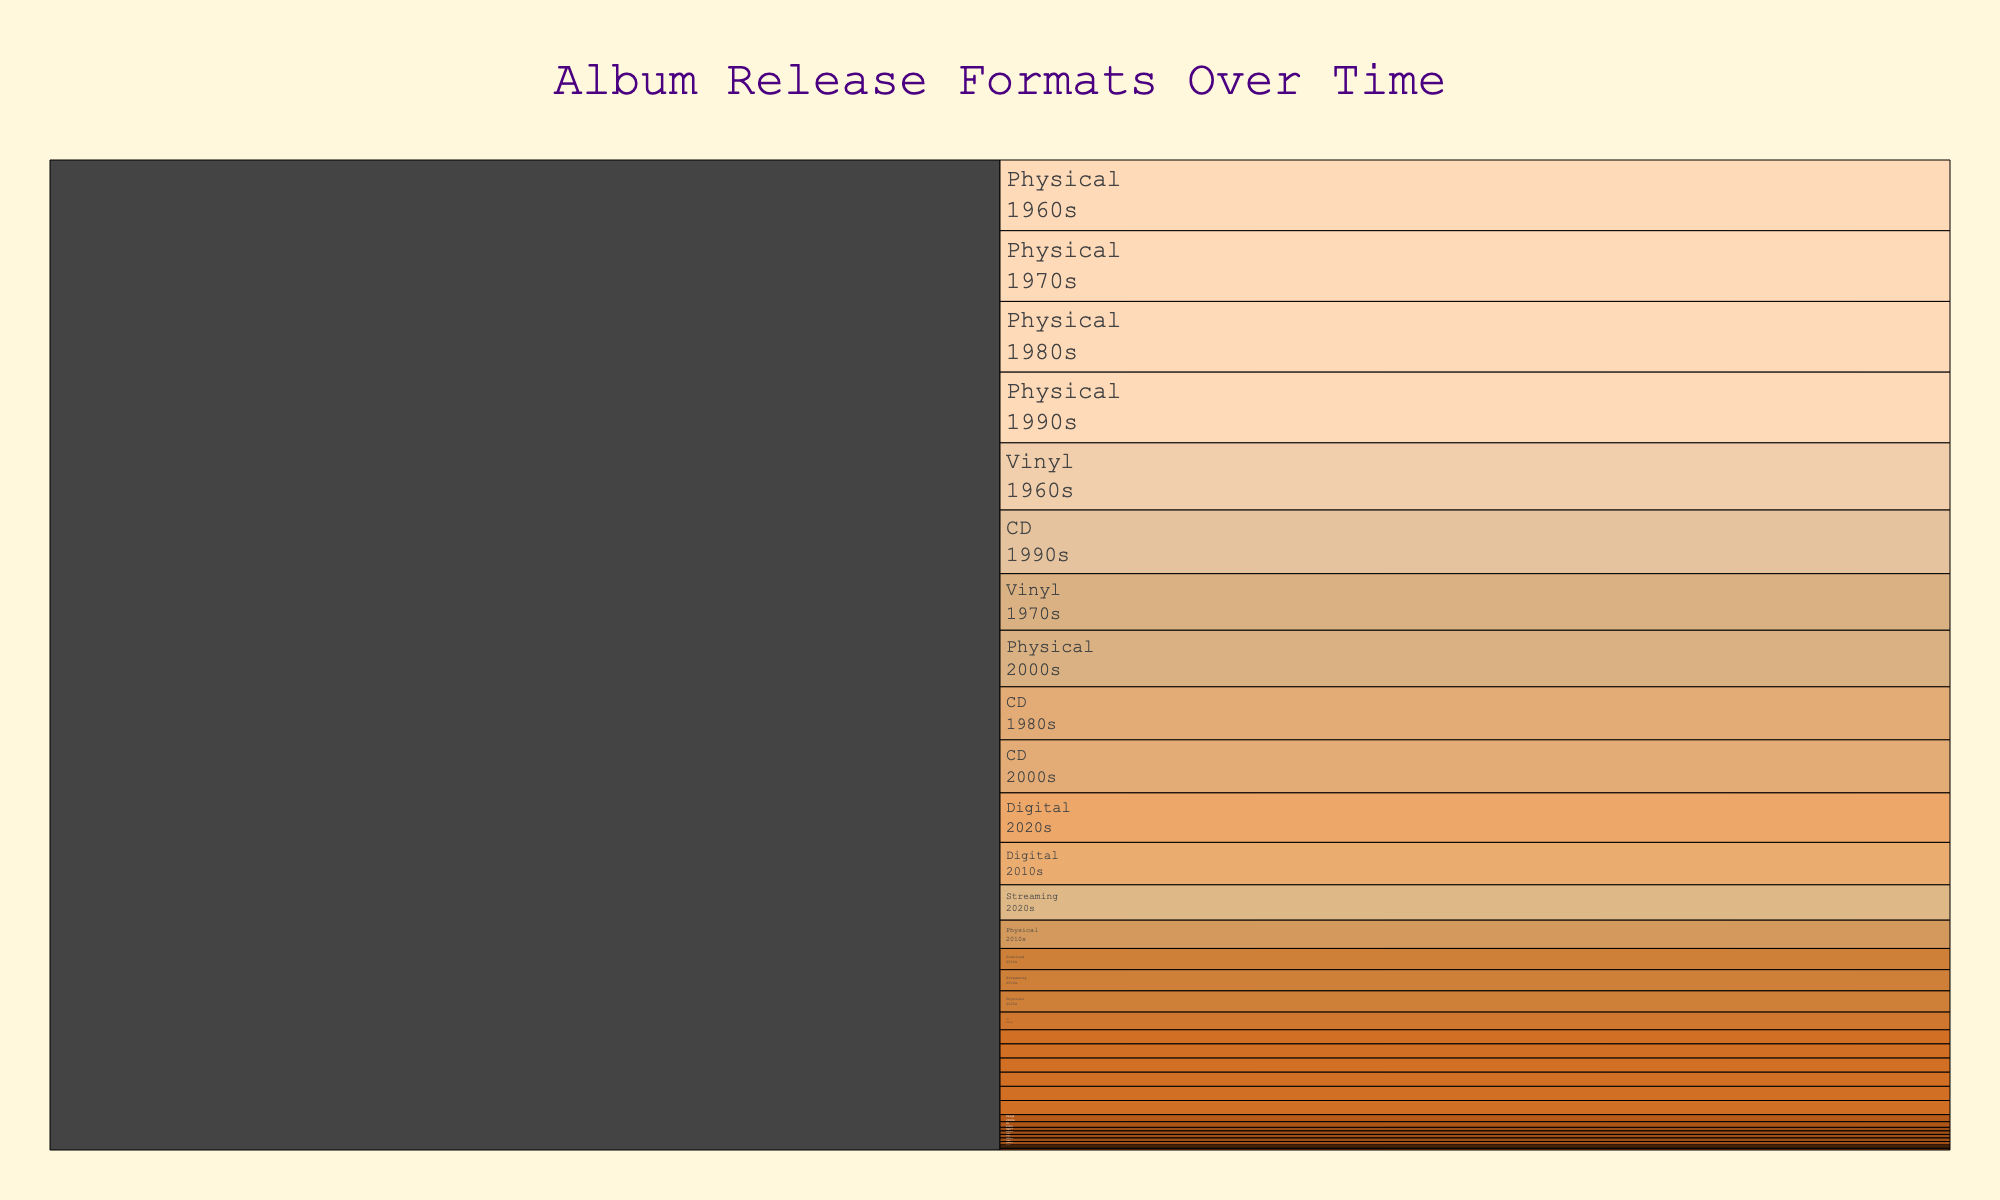what’s the title of the chart? The title is displayed at the top of the chart and reads "Album Release Formats Over Time"
Answer: Album Release Formats Over Time what format had the highest percentage in the 1960s? In the 1960s, Vinyl had the highest proportion at 95%.
Answer: Vinyl which format saw a substantial increase in the 2010s compared to the 2000s? By comparing the 2000s and 2010s data, Streaming significantly increased from 0% to 30%.
Answer: Streaming what’s the overall trend for the CD format from the 1980s to the 2020s? The CD format peaked in the 1990s with 90%, then saw a significant decline to 8% in the 2020s.
Answer: Declining how did the total percentage of physical formats compare to digital formats in the 2020s? Adding the percentages of physical (Vinyl, CD, Cassette) and digital (Download, Streaming) in the 2020s: 20% + 8% + 2% = 30% (physical), 20% + 50% = 70% (digital)
Answer: Digital had a higher percentage which decade saw the highest percentage for vinyl? The 1960s had the highest percentage for vinyl with 95%.
Answer: 1960s during which decades did cassettes have at least 5% of the album release formats? The decades are 1970s (20%), 1980s (5%), 1990s (5%), 2010s (5%), and 2020s (2%).
Answer: 1970s, 1980s, 1990s, 2010s what percentage of album releases were in digital formats in the 2000s? Adding Digital and Download percentages in the 2000s: 20%
Answer: 20% how does the percentage of vinyl in the 2020s compare to the percentage of CDs in the same decade? The percentages are 20% (Vinyl) and 8% (CD) in the 2020s, so Vinyl has a higher percentage.
Answer: Vinyl is higher 